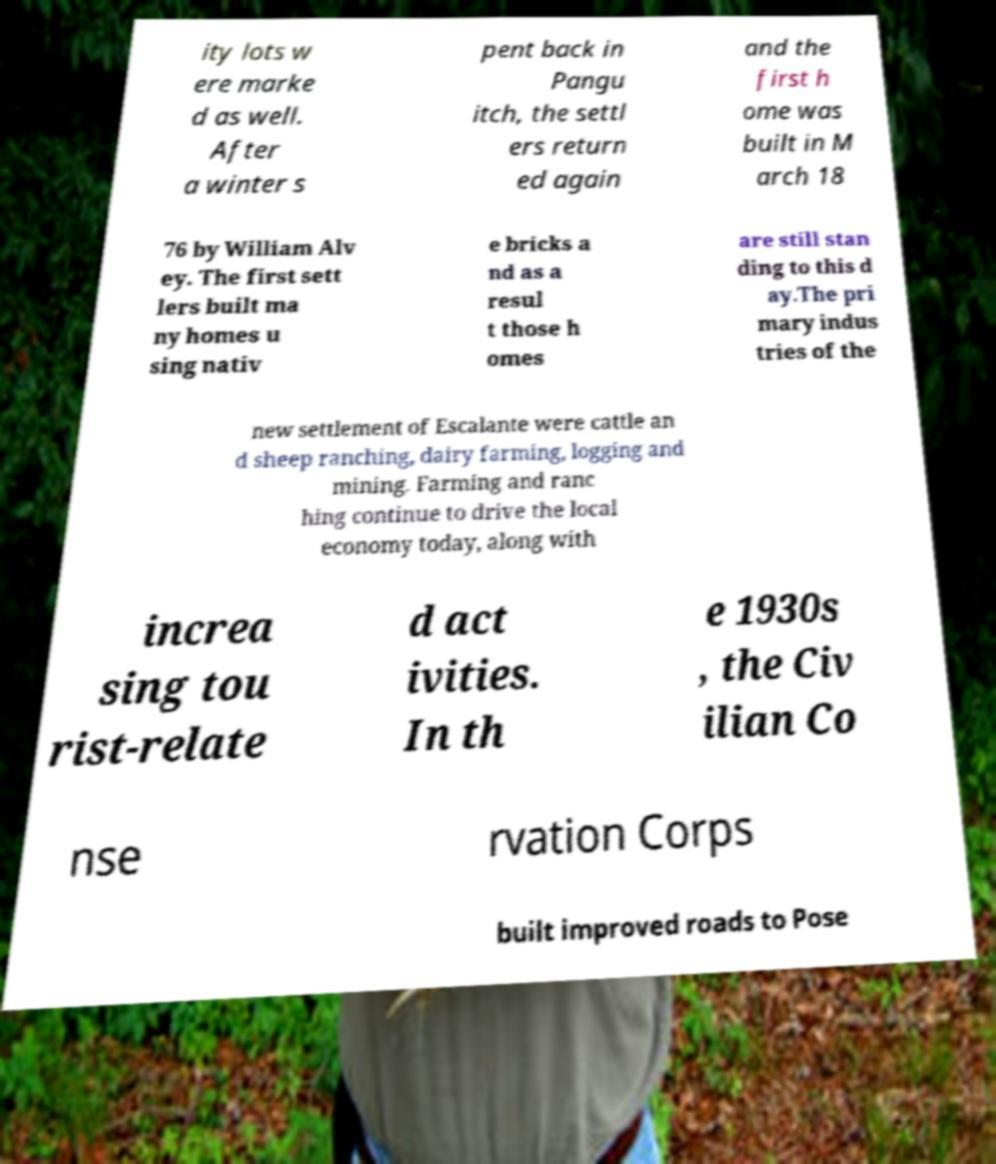There's text embedded in this image that I need extracted. Can you transcribe it verbatim? ity lots w ere marke d as well. After a winter s pent back in Pangu itch, the settl ers return ed again and the first h ome was built in M arch 18 76 by William Alv ey. The first sett lers built ma ny homes u sing nativ e bricks a nd as a resul t those h omes are still stan ding to this d ay.The pri mary indus tries of the new settlement of Escalante were cattle an d sheep ranching, dairy farming, logging and mining. Farming and ranc hing continue to drive the local economy today, along with increa sing tou rist-relate d act ivities. In th e 1930s , the Civ ilian Co nse rvation Corps built improved roads to Pose 